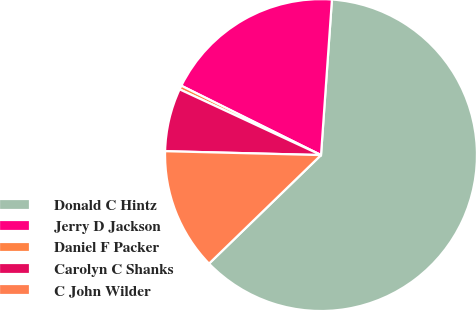Convert chart. <chart><loc_0><loc_0><loc_500><loc_500><pie_chart><fcel>Donald C Hintz<fcel>Jerry D Jackson<fcel>Daniel F Packer<fcel>Carolyn C Shanks<fcel>C John Wilder<nl><fcel>61.63%<fcel>18.78%<fcel>0.41%<fcel>6.53%<fcel>12.65%<nl></chart> 